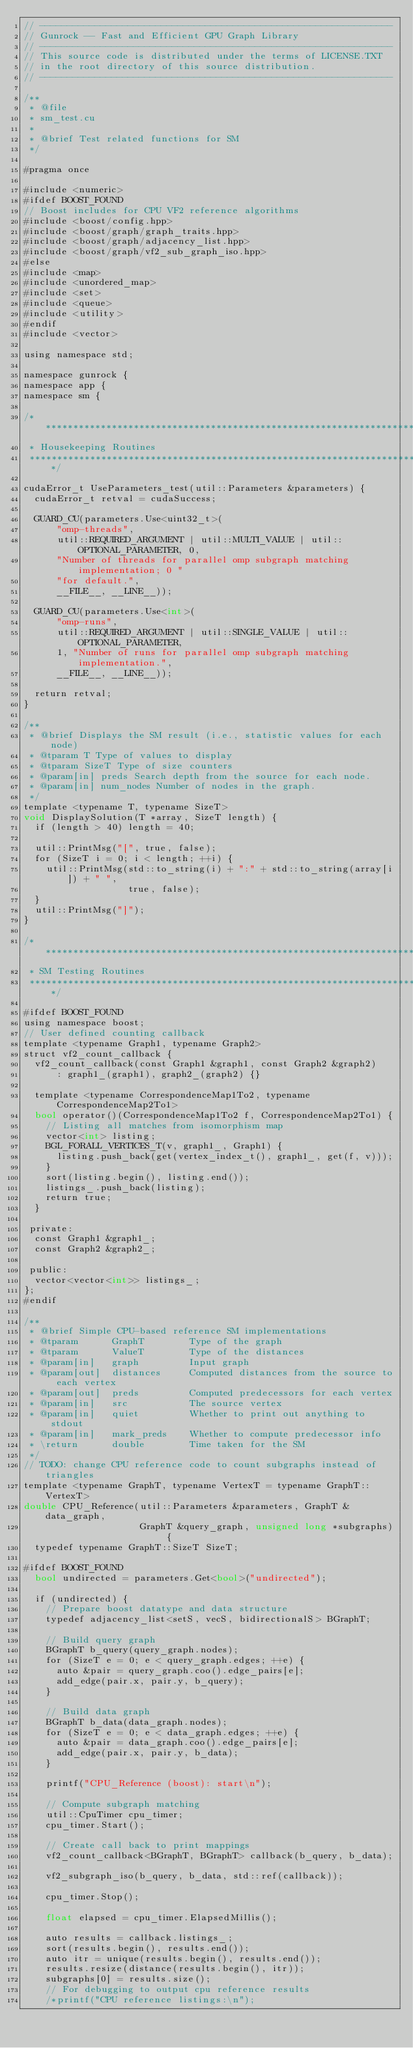Convert code to text. <code><loc_0><loc_0><loc_500><loc_500><_Cuda_>// ----------------------------------------------------------------
// Gunrock -- Fast and Efficient GPU Graph Library
// ----------------------------------------------------------------
// This source code is distributed under the terms of LICENSE.TXT
// in the root directory of this source distribution.
// ----------------------------------------------------------------

/**
 * @file
 * sm_test.cu
 *
 * @brief Test related functions for SM
 */

#pragma once

#include <numeric>
#ifdef BOOST_FOUND
// Boost includes for CPU VF2 reference algorithms
#include <boost/config.hpp>
#include <boost/graph/graph_traits.hpp>
#include <boost/graph/adjacency_list.hpp>
#include <boost/graph/vf2_sub_graph_iso.hpp>
#else
#include <map>
#include <unordered_map>
#include <set>
#include <queue>
#include <utility>
#endif
#include <vector>

using namespace std;

namespace gunrock {
namespace app {
namespace sm {

/******************************************************************************
 * Housekeeping Routines
 ******************************************************************************/

cudaError_t UseParameters_test(util::Parameters &parameters) {
  cudaError_t retval = cudaSuccess;

  GUARD_CU(parameters.Use<uint32_t>(
      "omp-threads",
      util::REQUIRED_ARGUMENT | util::MULTI_VALUE | util::OPTIONAL_PARAMETER, 0,
      "Number of threads for parallel omp subgraph matching implementation; 0 "
      "for default.",
      __FILE__, __LINE__));

  GUARD_CU(parameters.Use<int>(
      "omp-runs",
      util::REQUIRED_ARGUMENT | util::SINGLE_VALUE | util::OPTIONAL_PARAMETER,
      1, "Number of runs for parallel omp subgraph matching implementation.",
      __FILE__, __LINE__));

  return retval;
}

/**
 * @brief Displays the SM result (i.e., statistic values for each node)
 * @tparam T Type of values to display
 * @tparam SizeT Type of size counters
 * @param[in] preds Search depth from the source for each node.
 * @param[in] num_nodes Number of nodes in the graph.
 */
template <typename T, typename SizeT>
void DisplaySolution(T *array, SizeT length) {
  if (length > 40) length = 40;

  util::PrintMsg("[", true, false);
  for (SizeT i = 0; i < length; ++i) {
    util::PrintMsg(std::to_string(i) + ":" + std::to_string(array[i]) + " ",
                   true, false);
  }
  util::PrintMsg("]");
}

/******************************************************************************
 * SM Testing Routines
 *****************************************************************************/

#ifdef BOOST_FOUND
using namespace boost;
// User defined counting callback
template <typename Graph1, typename Graph2>
struct vf2_count_callback {
  vf2_count_callback(const Graph1 &graph1, const Graph2 &graph2)
      : graph1_(graph1), graph2_(graph2) {}

  template <typename CorrespondenceMap1To2, typename CorrespondenceMap2To1>
  bool operator()(CorrespondenceMap1To2 f, CorrespondenceMap2To1) {
    // Listing all matches from isomorphism map
    vector<int> listing;
    BGL_FORALL_VERTICES_T(v, graph1_, Graph1) {
      listing.push_back(get(vertex_index_t(), graph1_, get(f, v)));
    }
    sort(listing.begin(), listing.end());
    listings_.push_back(listing);
    return true;
  }

 private:
  const Graph1 &graph1_;
  const Graph2 &graph2_;

 public:
  vector<vector<int>> listings_;
};
#endif

/**
 * @brief Simple CPU-based reference SM implementations
 * @tparam      GraphT        Type of the graph
 * @tparam      ValueT        Type of the distances
 * @param[in]   graph         Input graph
 * @param[out]  distances     Computed distances from the source to each vertex
 * @param[out]  preds         Computed predecessors for each vertex
 * @param[in]   src           The source vertex
 * @param[in]   quiet         Whether to print out anything to stdout
 * @param[in]   mark_preds    Whether to compute predecessor info
 * \return      double        Time taken for the SM
 */
// TODO: change CPU reference code to count subgraphs instead of triangles
template <typename GraphT, typename VertexT = typename GraphT::VertexT>
double CPU_Reference(util::Parameters &parameters, GraphT &data_graph,
                     GraphT &query_graph, unsigned long *subgraphs) {
  typedef typename GraphT::SizeT SizeT;

#ifdef BOOST_FOUND
  bool undirected = parameters.Get<bool>("undirected");

  if (undirected) {
    // Prepare boost datatype and data structure
    typedef adjacency_list<setS, vecS, bidirectionalS> BGraphT;

    // Build query graph
    BGraphT b_query(query_graph.nodes);
    for (SizeT e = 0; e < query_graph.edges; ++e) {
      auto &pair = query_graph.coo().edge_pairs[e];
      add_edge(pair.x, pair.y, b_query);
    }

    // Build data graph
    BGraphT b_data(data_graph.nodes);
    for (SizeT e = 0; e < data_graph.edges; ++e) {
      auto &pair = data_graph.coo().edge_pairs[e];
      add_edge(pair.x, pair.y, b_data);
    }

    printf("CPU_Reference (boost): start\n");

    // Compute subgraph matching
    util::CpuTimer cpu_timer;
    cpu_timer.Start();

    // Create call back to print mappings
    vf2_count_callback<BGraphT, BGraphT> callback(b_query, b_data);

    vf2_subgraph_iso(b_query, b_data, std::ref(callback));

    cpu_timer.Stop();

    float elapsed = cpu_timer.ElapsedMillis();

    auto results = callback.listings_;
    sort(results.begin(), results.end());
    auto itr = unique(results.begin(), results.end());
    results.resize(distance(results.begin(), itr));
    subgraphs[0] = results.size();
    // For debugging to output cpu reference results
    /*printf("CPU reference listings:\n");</code> 